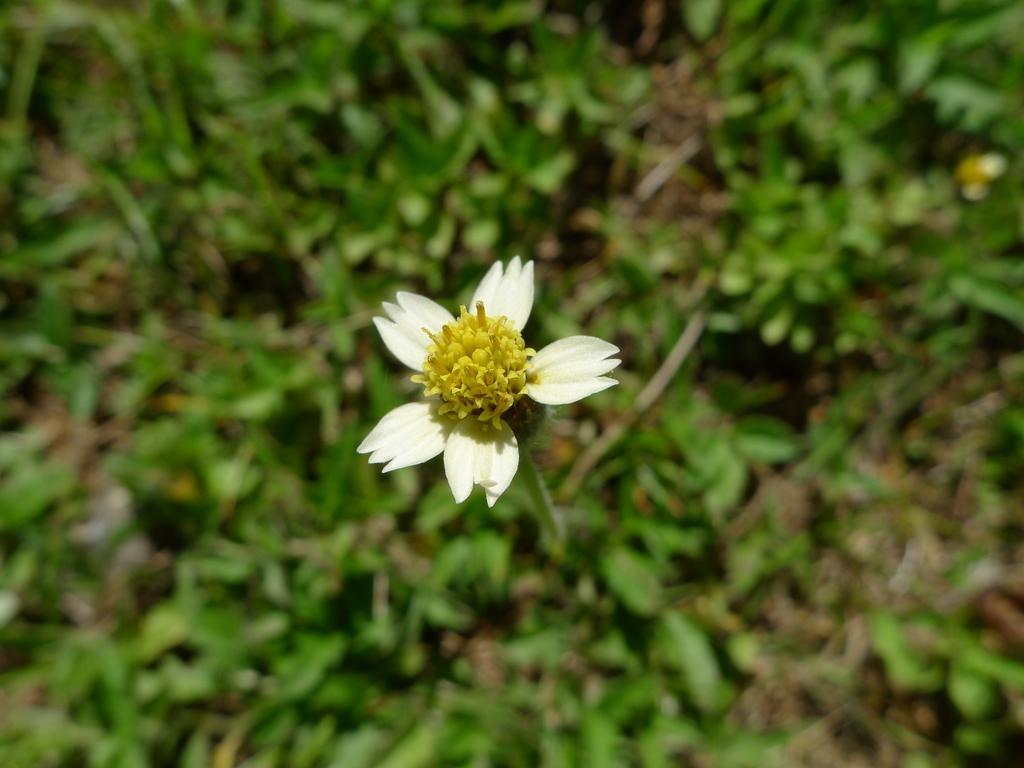Please provide a concise description of this image. In the center of the image there is a flower. In the background we can see grass. 